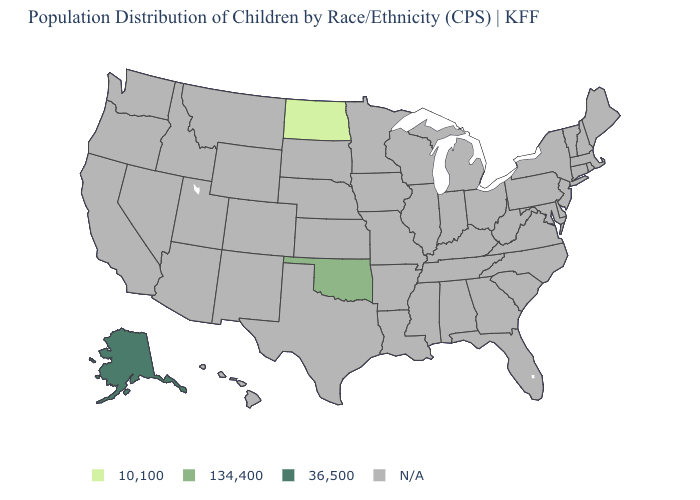Which states hav the highest value in the West?
Answer briefly. Alaska. Name the states that have a value in the range N/A?
Answer briefly. Alabama, Arizona, Arkansas, California, Colorado, Connecticut, Delaware, Florida, Georgia, Hawaii, Idaho, Illinois, Indiana, Iowa, Kansas, Kentucky, Louisiana, Maine, Maryland, Massachusetts, Michigan, Minnesota, Mississippi, Missouri, Montana, Nebraska, Nevada, New Hampshire, New Jersey, New Mexico, New York, North Carolina, Ohio, Oregon, Pennsylvania, Rhode Island, South Carolina, South Dakota, Tennessee, Texas, Utah, Vermont, Virginia, Washington, West Virginia, Wisconsin, Wyoming. What is the value of Massachusetts?
Write a very short answer. N/A. Does the map have missing data?
Quick response, please. Yes. What is the highest value in the MidWest ?
Answer briefly. 10,100. What is the lowest value in the USA?
Concise answer only. 10,100. Which states have the lowest value in the USA?
Give a very brief answer. North Dakota. Name the states that have a value in the range 134,400?
Write a very short answer. Oklahoma. Name the states that have a value in the range 10,100?
Quick response, please. North Dakota. What is the highest value in the MidWest ?
Quick response, please. 10,100. Name the states that have a value in the range 134,400?
Answer briefly. Oklahoma. What is the value of Ohio?
Give a very brief answer. N/A. Name the states that have a value in the range 10,100?
Short answer required. North Dakota. 